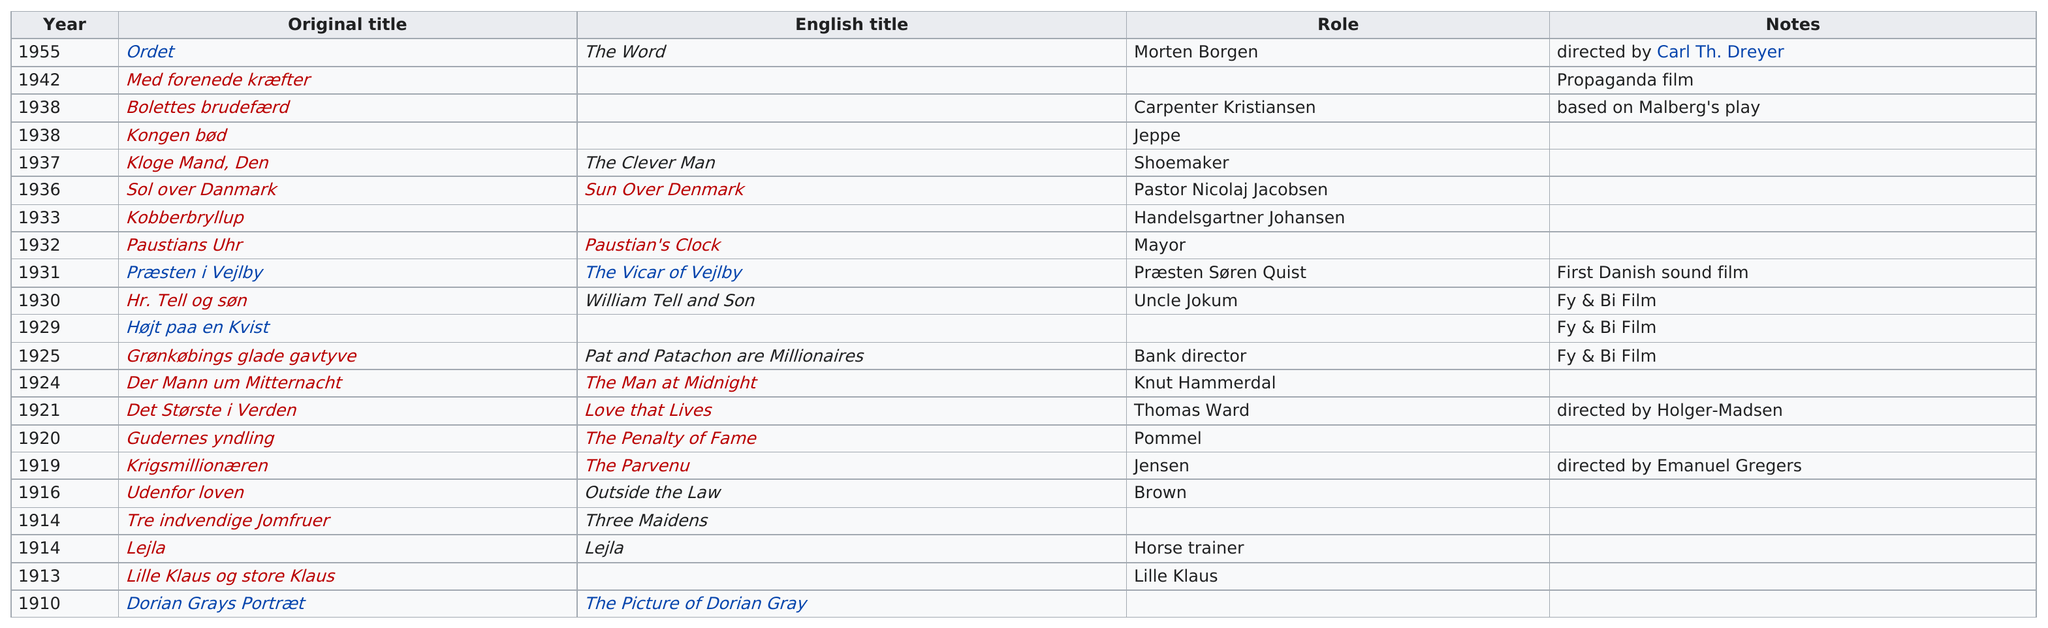Point out several critical features in this image. Malberg was involved in 3 consecutive films that were categorized as "fy and bi films. After "lejila," what was Malberg's next film? "Lille Klaus og store Klaus... Henrick Malberg's last film was 'Ordet,' which was released before his death. Malberg starred in the film "The Man at Midnight" after his appearance in "Love That Lives. 21 years had passed from Malberg's first film to the first Danish film with sound. 